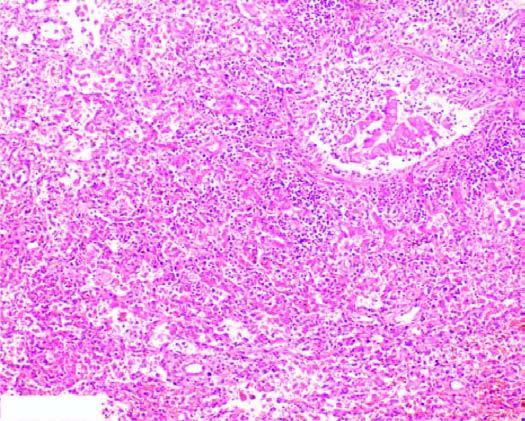what are the bronchioles as well as the adjacent alveoli filled with?
Answer the question using a single word or phrase. Exudate consisting chiefly of neutrophils 